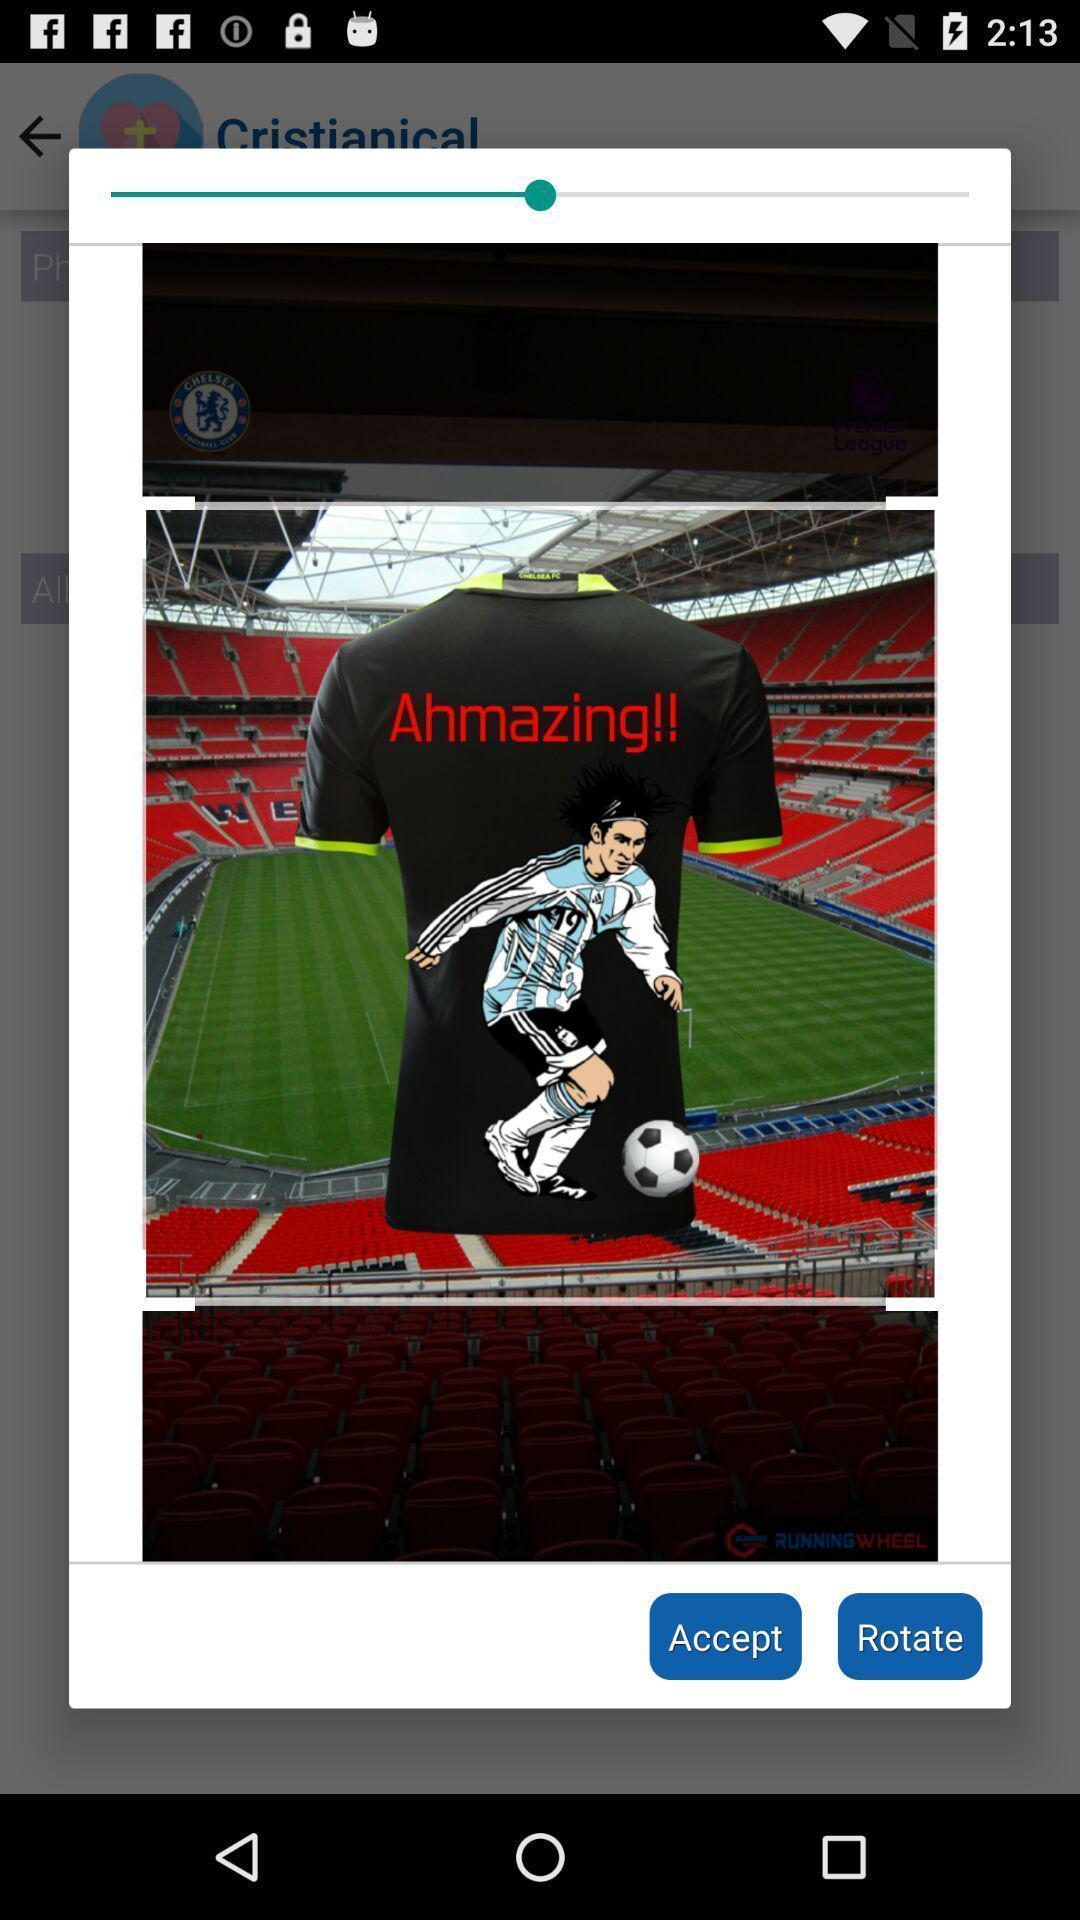Describe the content in this image. Pop up alert showing image with accept and rotate options. 